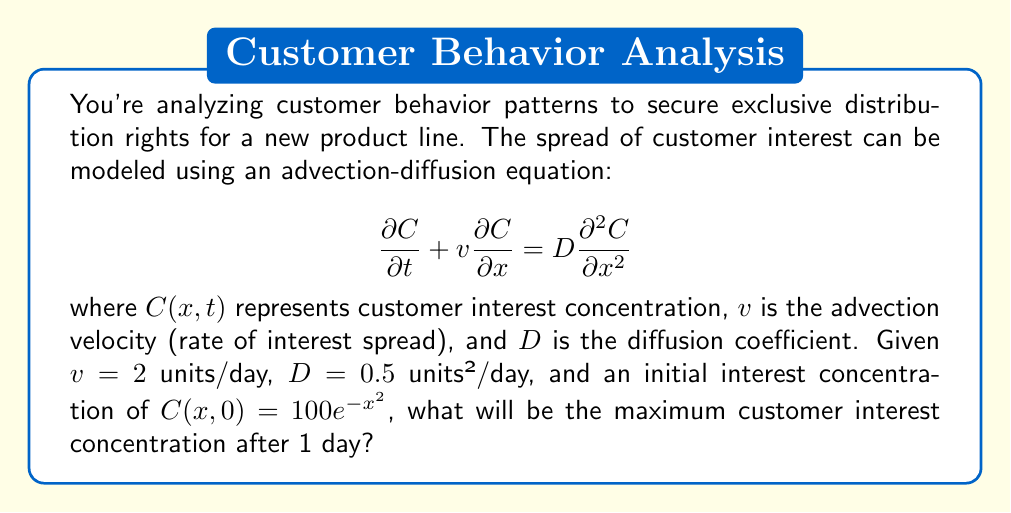Teach me how to tackle this problem. To solve this problem, we need to use the fundamental solution of the advection-diffusion equation, which is given by:

$$C(x,t) = \frac{1}{\sqrt{4\pi Dt}} \int_{-\infty}^{\infty} C(y,0) \exp\left(-\frac{(x-y-vt)^2}{4Dt}\right) dy$$

Where $C(y,0)$ is the initial concentration distribution.

Given:
- $v = 2$ units/day
- $D = 0.5$ units²/day
- $t = 1$ day
- $C(x,0) = 100e^{-x^2}$

Substituting these values into the fundamental solution:

$$C(x,1) = \frac{100}{\sqrt{4\pi(0.5)(1)}} \int_{-\infty}^{\infty} e^{-y^2} \exp\left(-\frac{(x-y-2)^2}{4(0.5)(1)}\right) dy$$

$$C(x,1) = \frac{100}{\sqrt{2\pi}} \int_{-\infty}^{\infty} e^{-y^2} \exp\left(-\frac{(x-y-2)^2}{2}\right) dy$$

This integral can be evaluated to give:

$$C(x,1) = \frac{100}{\sqrt{3}} \exp\left(-\frac{(x-2)^2}{3}\right)$$

To find the maximum concentration, we need to find the value of $x$ where $\frac{\partial C}{\partial x} = 0$:

$$\frac{\partial C}{\partial x} = -\frac{200(x-2)}{3\sqrt{3}} \exp\left(-\frac{(x-2)^2}{3}\right) = 0$$

This occurs when $x = 2$, which corresponds to the peak of the Gaussian distribution.

The maximum concentration is therefore:

$$C_{max} = C(2,1) = \frac{100}{\sqrt{3}} \exp(0) = \frac{100}{\sqrt{3}}$$
Answer: $\frac{100}{\sqrt{3}} \approx 57.74$ units of customer interest concentration 